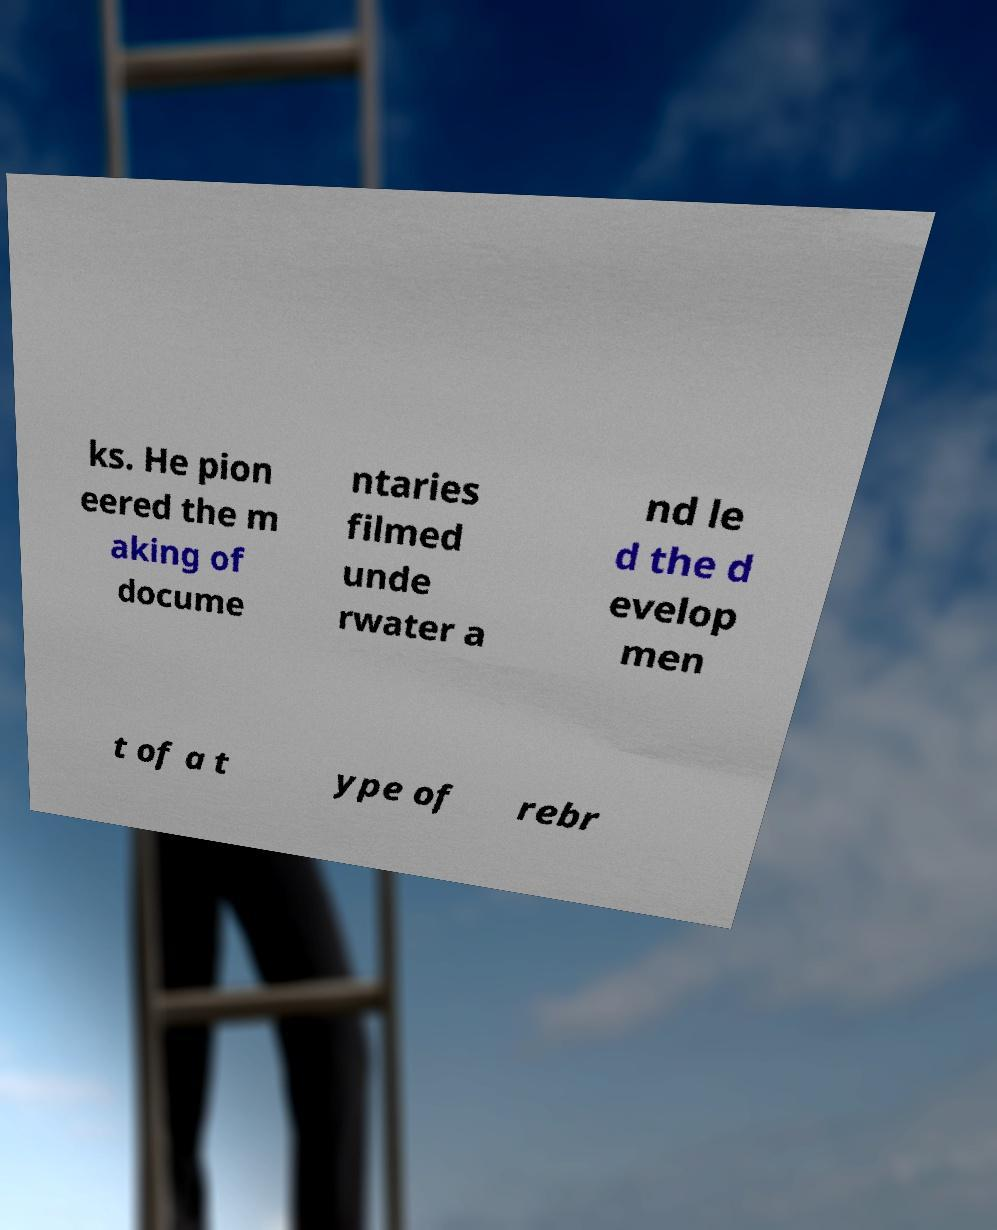What messages or text are displayed in this image? I need them in a readable, typed format. ks. He pion eered the m aking of docume ntaries filmed unde rwater a nd le d the d evelop men t of a t ype of rebr 